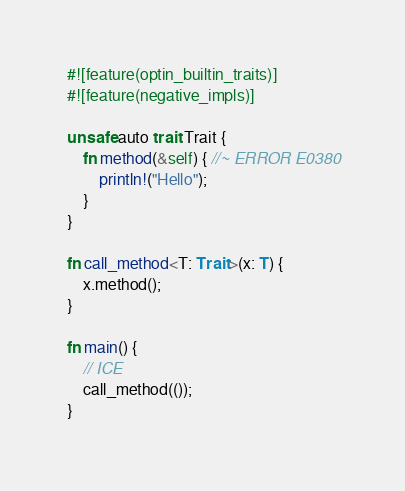Convert code to text. <code><loc_0><loc_0><loc_500><loc_500><_Rust_>#![feature(optin_builtin_traits)]
#![feature(negative_impls)]

unsafe auto trait Trait {
    fn method(&self) { //~ ERROR E0380
        println!("Hello");
    }
}

fn call_method<T: Trait>(x: T) {
    x.method();
}

fn main() {
    // ICE
    call_method(());
}
</code> 